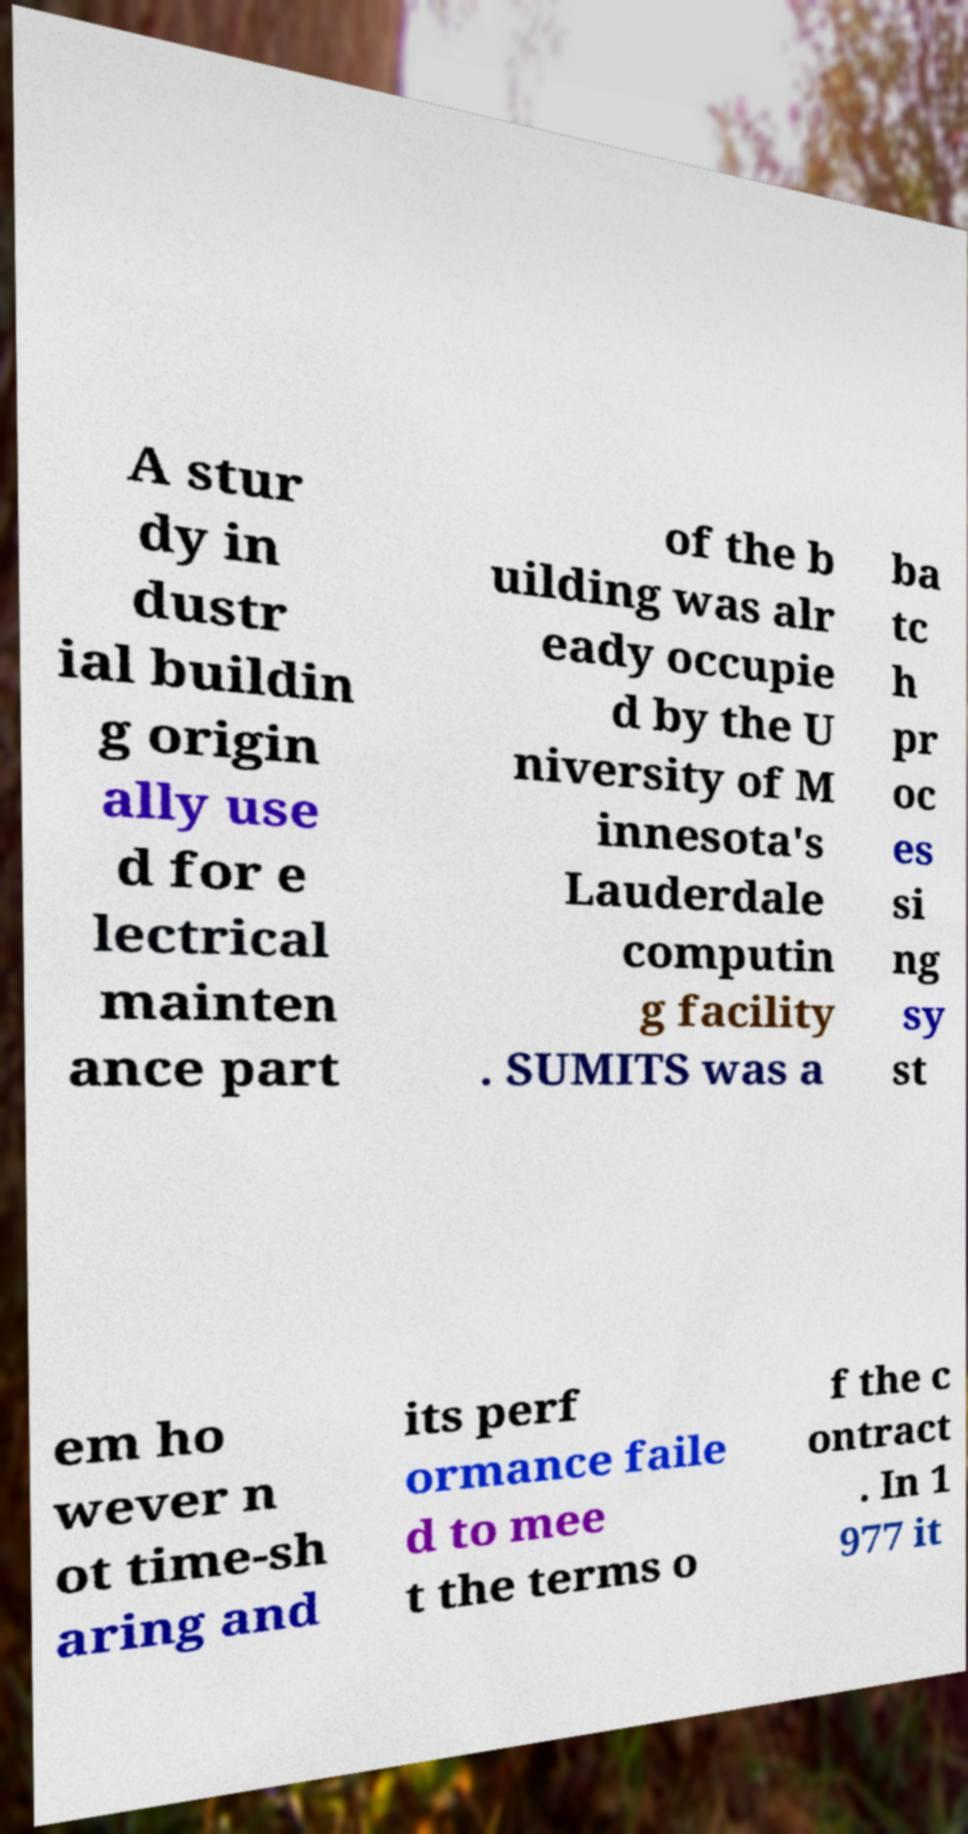For documentation purposes, I need the text within this image transcribed. Could you provide that? A stur dy in dustr ial buildin g origin ally use d for e lectrical mainten ance part of the b uilding was alr eady occupie d by the U niversity of M innesota's Lauderdale computin g facility . SUMITS was a ba tc h pr oc es si ng sy st em ho wever n ot time-sh aring and its perf ormance faile d to mee t the terms o f the c ontract . In 1 977 it 